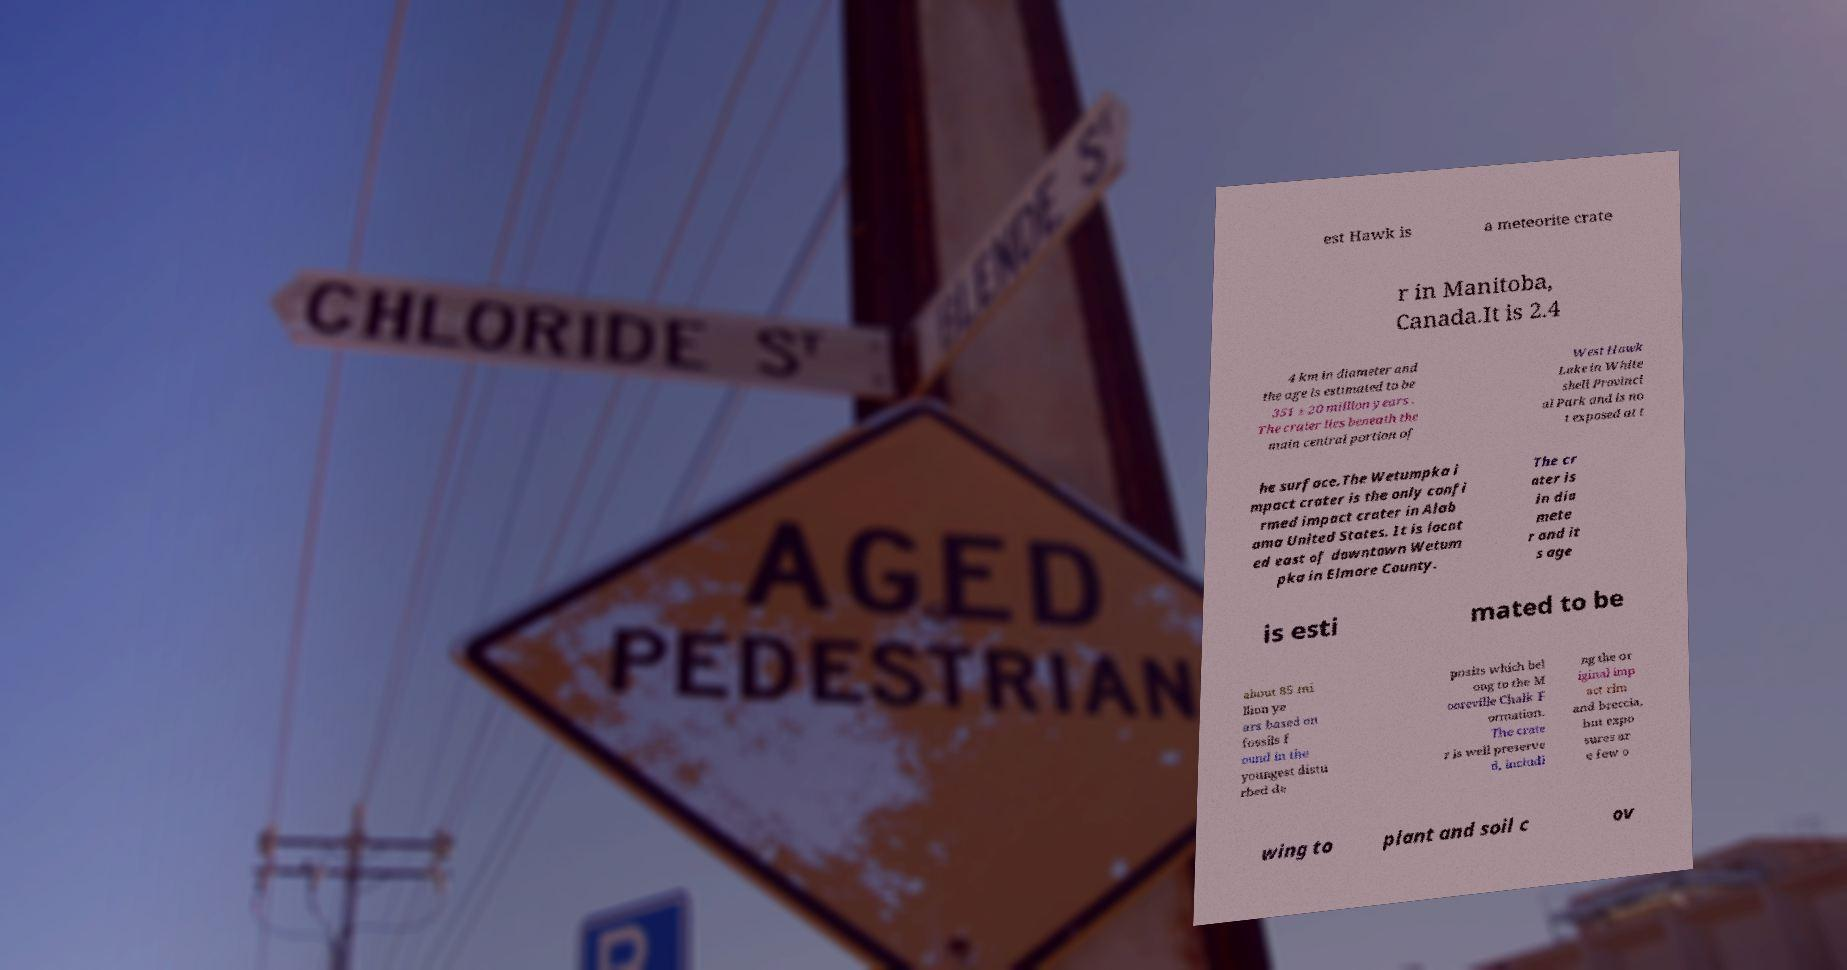What messages or text are displayed in this image? I need them in a readable, typed format. est Hawk is a meteorite crate r in Manitoba, Canada.It is 2.4 4 km in diameter and the age is estimated to be 351 ± 20 million years . The crater lies beneath the main central portion of West Hawk Lake in White shell Provinci al Park and is no t exposed at t he surface.The Wetumpka i mpact crater is the only confi rmed impact crater in Alab ama United States. It is locat ed east of downtown Wetum pka in Elmore County. The cr ater is in dia mete r and it s age is esti mated to be about 85 mi llion ye ars based on fossils f ound in the youngest distu rbed de posits which bel ong to the M ooreville Chalk F ormation. The crate r is well preserve d, includi ng the or iginal imp act rim and breccia, but expo sures ar e few o wing to plant and soil c ov 